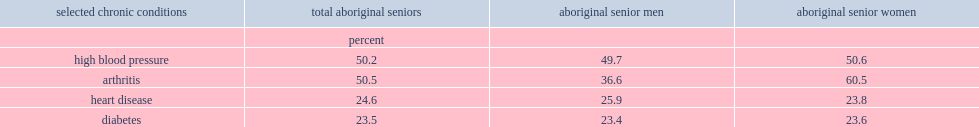List top two chronic conditions that are the most commonly reported chronic conditions by aboriginal seniors in population centres in 2012. High blood pressure arthritis. What are the rates of both aboriginal senior men and aboriginal senior women reported being diagnosed with high blood pressure, respectively? 49.7 50.6. Which group of people is more likely to report bing diagnosed with arthritis? aboriginal senior men or women? Aboriginal senior women. 